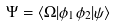Convert formula to latex. <formula><loc_0><loc_0><loc_500><loc_500>\Psi = \langle \Omega | \phi _ { 1 } \phi _ { 2 } | \psi \rangle</formula> 